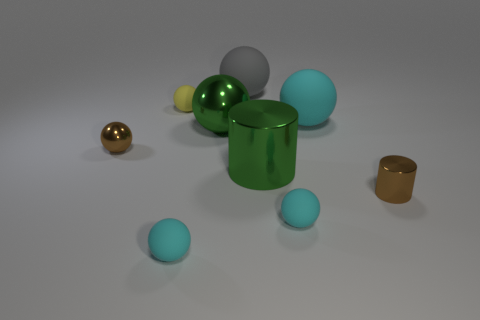Is there a large object of the same color as the large metal cylinder?
Your answer should be very brief. Yes. Does the brown shiny object that is to the left of the small yellow ball have the same shape as the big gray thing?
Provide a short and direct response. Yes. What color is the large ball that is the same material as the large gray thing?
Your answer should be compact. Cyan. There is a cyan sphere that is behind the big cylinder; what material is it?
Provide a short and direct response. Rubber. Is the shape of the tiny yellow rubber thing the same as the tiny cyan thing right of the big metallic ball?
Give a very brief answer. Yes. There is a tiny thing that is to the right of the large green cylinder and on the left side of the small metallic cylinder; what material is it?
Your answer should be compact. Rubber. The cylinder that is the same size as the yellow matte object is what color?
Provide a short and direct response. Brown. Is the tiny yellow object made of the same material as the gray ball that is on the right side of the large metal ball?
Your answer should be compact. Yes. What number of other objects are there of the same size as the yellow object?
Your response must be concise. 4. There is a large cyan matte thing that is in front of the large gray rubber ball that is right of the big green shiny ball; are there any tiny brown cylinders that are to the right of it?
Offer a terse response. Yes. 